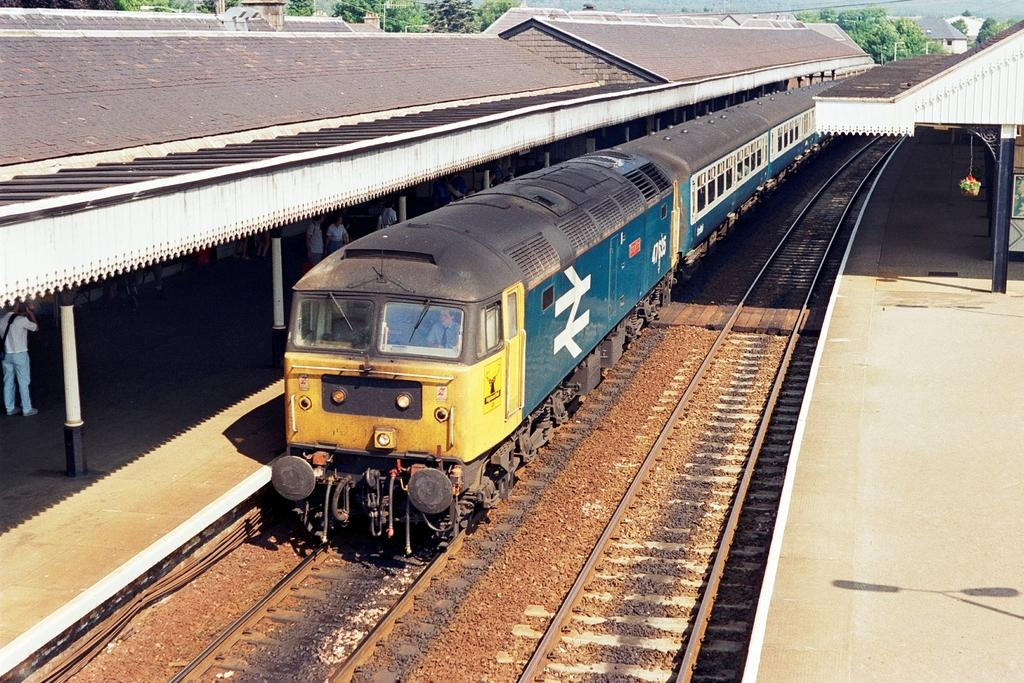What is the main subject of the image? The main subject of the image is a train. Where is the train located in the image? The train is on a track. What can be seen beside the train in the image? There are people on a platform beside the train. What is visible in the background of the image? Trees and buildings are visible in the background of the image. What type of fear can be seen on the faces of the people on the platform in the image? There is no indication of fear on the faces of the people on the platform in the image. How many snakes are visible on the train in the image? There are no snakes visible on the train or in the image. 